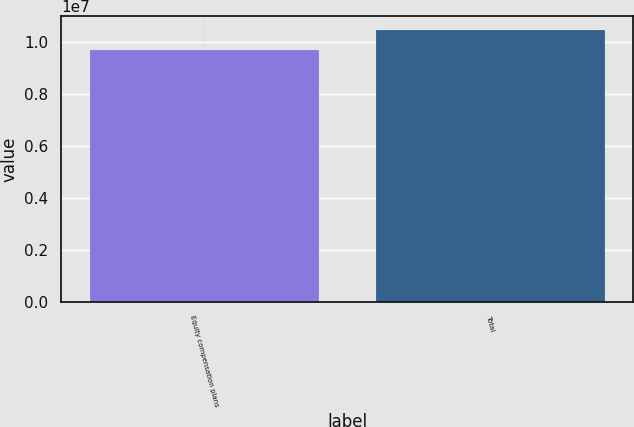<chart> <loc_0><loc_0><loc_500><loc_500><bar_chart><fcel>Equity compensation plans<fcel>Total<nl><fcel>9.68306e+06<fcel>1.04594e+07<nl></chart> 